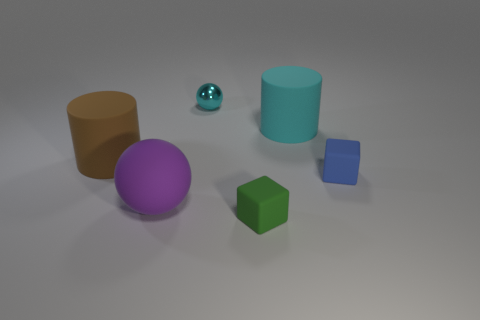What is the purple thing made of?
Provide a short and direct response. Rubber. Are there any other things that are the same color as the metal object?
Provide a short and direct response. Yes. Is the shape of the purple matte thing the same as the metal object?
Provide a succinct answer. Yes. There is a rubber object that is in front of the big matte thing that is in front of the rubber cube to the right of the green object; how big is it?
Provide a succinct answer. Small. What number of other objects are there of the same material as the small cyan object?
Your answer should be very brief. 0. What color is the small rubber thing that is behind the tiny green matte object?
Keep it short and to the point. Blue. There is a cyan object on the left side of the small matte object that is to the left of the cube that is to the right of the green block; what is its material?
Your answer should be very brief. Metal. Are there any cyan objects of the same shape as the brown rubber object?
Your answer should be very brief. Yes. What shape is the cyan object that is the same size as the brown cylinder?
Ensure brevity in your answer.  Cylinder. How many matte things are behind the large purple ball and on the right side of the tiny cyan sphere?
Give a very brief answer. 2. 